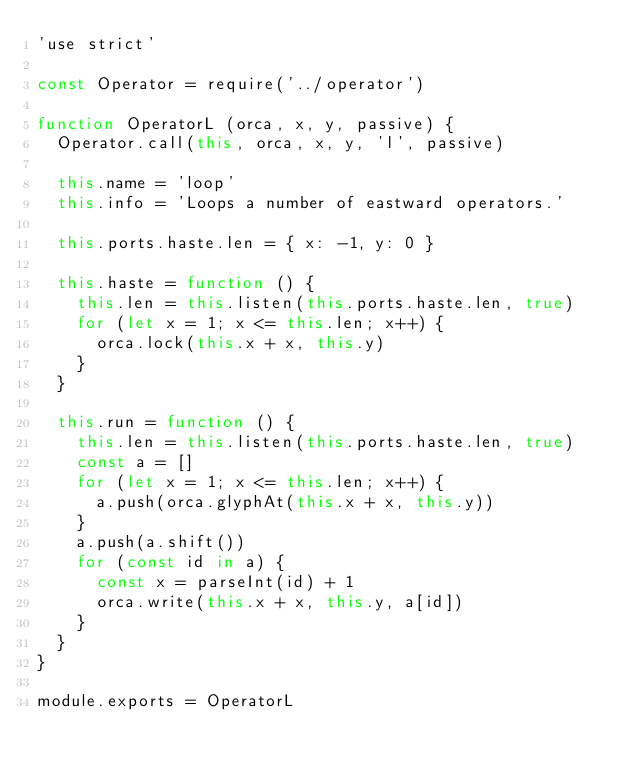<code> <loc_0><loc_0><loc_500><loc_500><_JavaScript_>'use strict'

const Operator = require('../operator')

function OperatorL (orca, x, y, passive) {
  Operator.call(this, orca, x, y, 'l', passive)

  this.name = 'loop'
  this.info = 'Loops a number of eastward operators.'

  this.ports.haste.len = { x: -1, y: 0 }

  this.haste = function () {
    this.len = this.listen(this.ports.haste.len, true)
    for (let x = 1; x <= this.len; x++) {
      orca.lock(this.x + x, this.y)
    }
  }

  this.run = function () {
    this.len = this.listen(this.ports.haste.len, true)
    const a = []
    for (let x = 1; x <= this.len; x++) {
      a.push(orca.glyphAt(this.x + x, this.y))
    }
    a.push(a.shift())
    for (const id in a) {
      const x = parseInt(id) + 1
      orca.write(this.x + x, this.y, a[id])
    }
  }
}

module.exports = OperatorL
</code> 